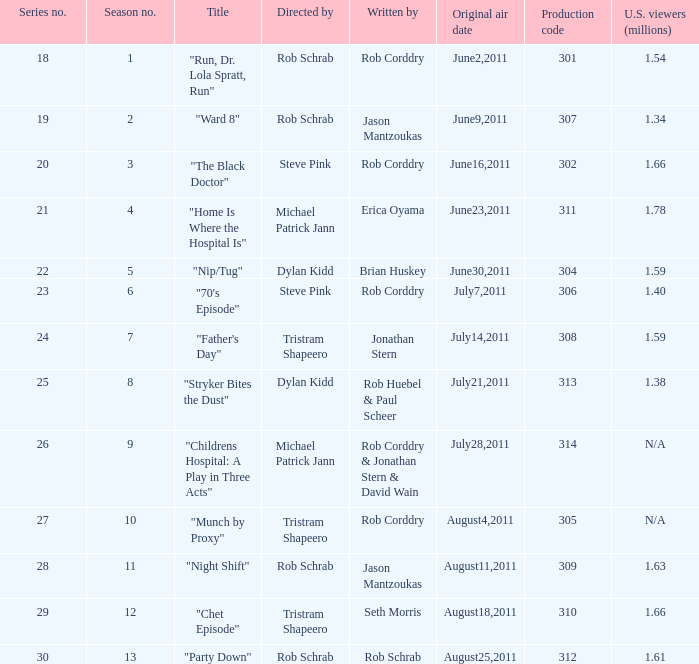The episode entitled "ward 8" was what number in the series? 19.0. 